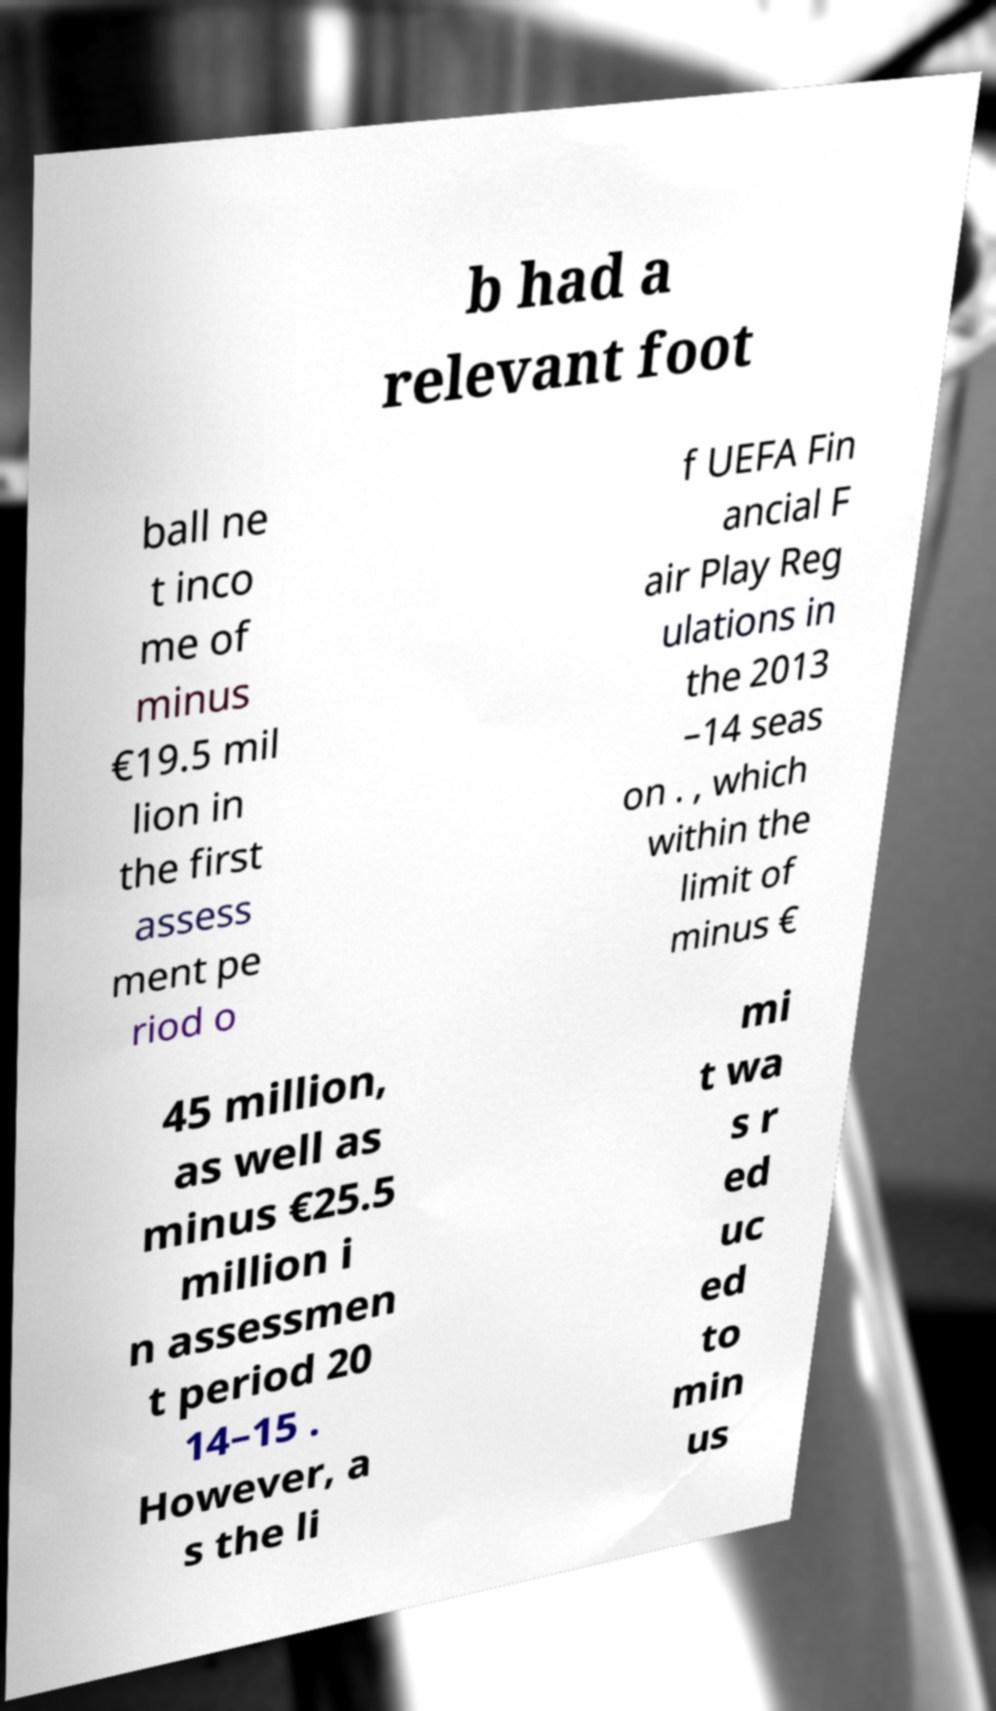Can you accurately transcribe the text from the provided image for me? b had a relevant foot ball ne t inco me of minus €19.5 mil lion in the first assess ment pe riod o f UEFA Fin ancial F air Play Reg ulations in the 2013 –14 seas on . , which within the limit of minus € 45 million, as well as minus €25.5 million i n assessmen t period 20 14–15 . However, a s the li mi t wa s r ed uc ed to min us 